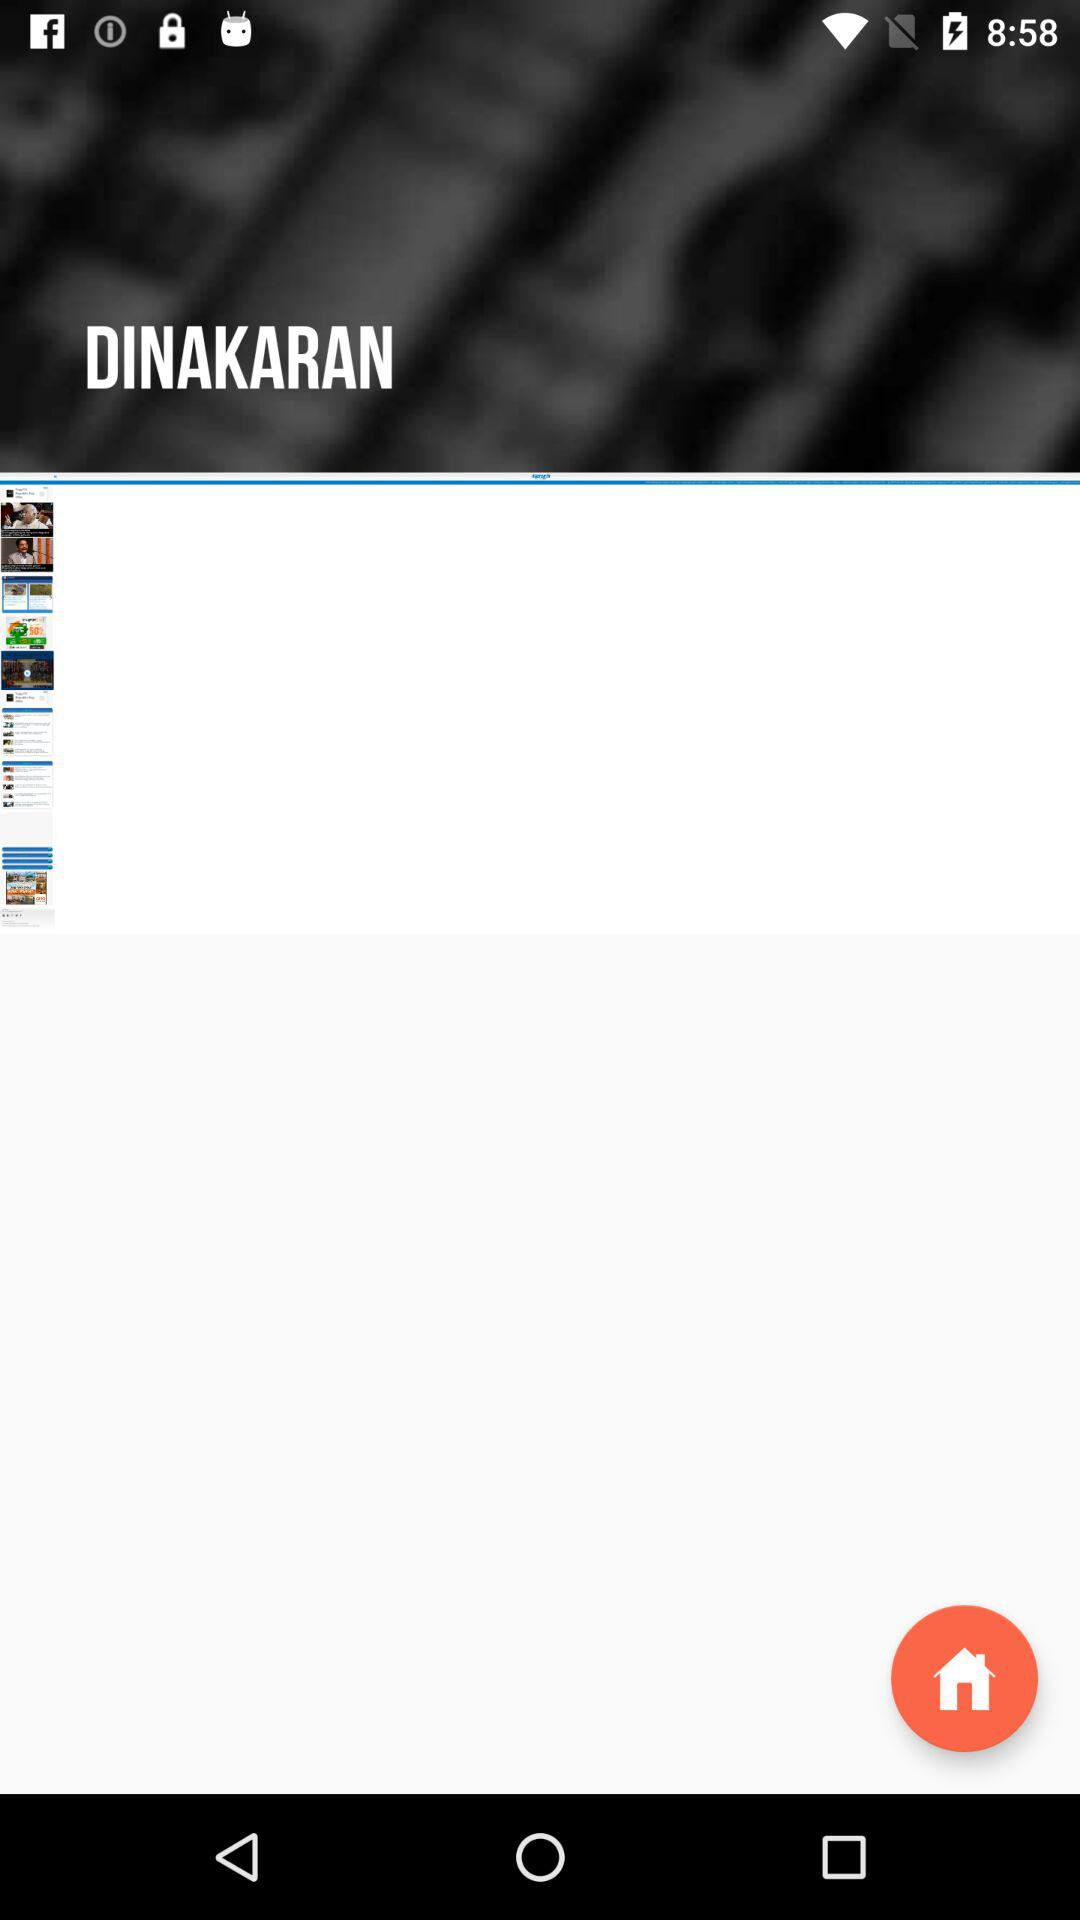What is the name of the application? The application name is "DINAKARAN". 